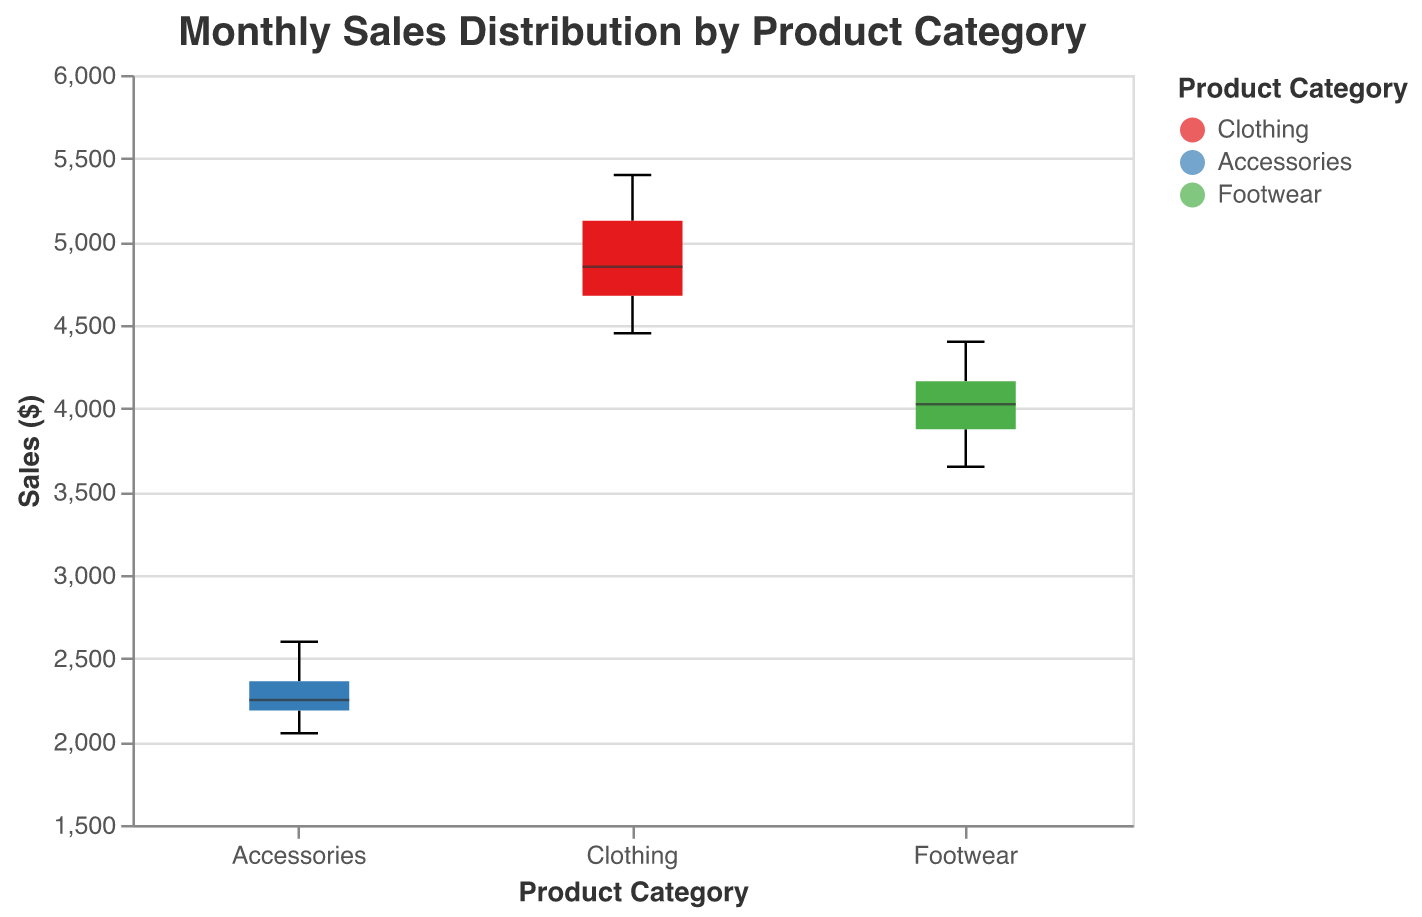What's the title of the chart? The title of the chart is displayed at the top and reads "Monthly Sales Distribution by Product Category".
Answer: Monthly Sales Distribution by Product Category Which product category has the highest median sales? The median sales value is marked by a line inside each box in the box plot. By comparing the positions of these lines, we see that Clothing has the highest median sales.
Answer: Clothing What is the range of sales for Accessories? The box plot displays the minimum and maximum sales values by the whiskers. For Accessories, the sales range from around $2050 to $2600.
Answer: $2050 - $2600 Which product category shows the most variation in sales? The variability in sales can be assessed by looking at the interquartile range (IQR), which is the width of the box. Clothing has the widest box indicating the highest sales variation.
Answer: Clothing Are the sales of any product category notched significantly from another? Notches in a box plot represent the confidence intervals for the median, and if notches between two boxes do not overlap, it indicates that their medians are significantly different. There is no significant overlap between the notches of Clothing and Accessories.
Answer: Yes, between Clothing and Accessories List the product categories in order of their median sales from highest to lowest. By comparing the lines indicating median sales within the boxes, the order from highest to lowest is: Clothing, Footwear, Accessories.
Answer: Clothing, Footwear, Accessories What is the interquartile range (IQR) of Footwear sales? The IQR is the range of the middle 50% of data points, represented by the width of the box. For Footwear, it spans from around $3800 to $4200.
Answer: $400 Which product category has the smallest range of sales? The range of sales is shown by the length of the whiskers. Accessories, with whiskers spanning from around $2050 to $2600, has the smallest range.
Answer: Accessories Is there any overlap in the range of sales between Clothing and Footwear? To determine the overlap, compare the whiskers' ends of Clothing and Footwear. Clothing ranges from $4450 to $5400 and Footwear from $3650 to $4400, so there is no overlap.
Answer: No What can you infer about the sales variability of Accessories compared to Footwear? Accessories have a smaller box, indicating a smaller interquartile range, and shorter whiskers, indicating less variability compared to Footwear sales.
Answer: Less variability in Accessories sales compared to Footwear 